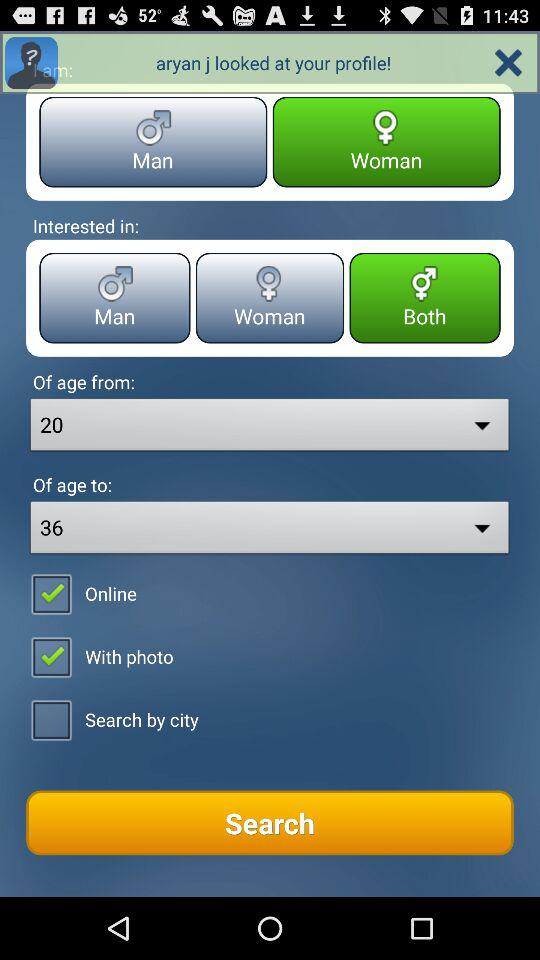What is the status of "Online"? The status is "on". 